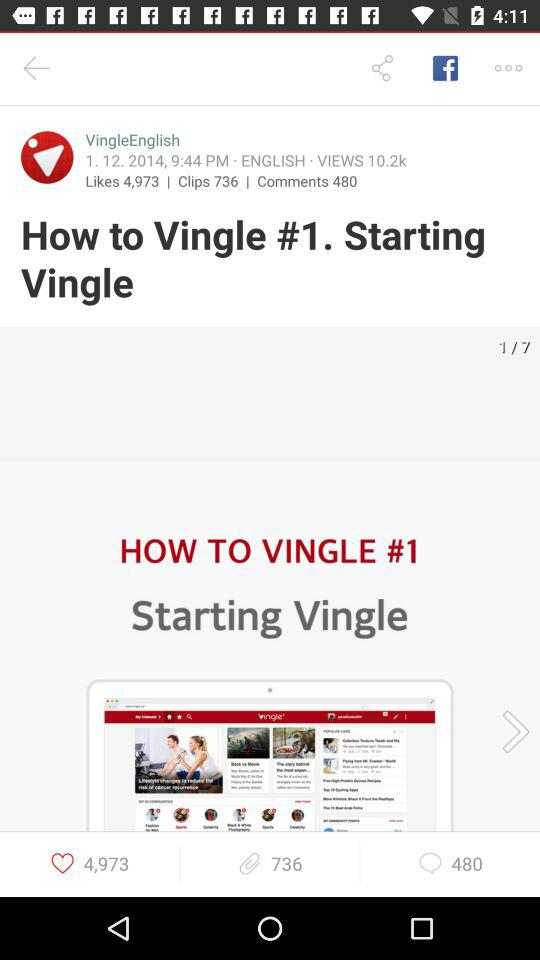What's the number of views? The number of views is 10.2k. 